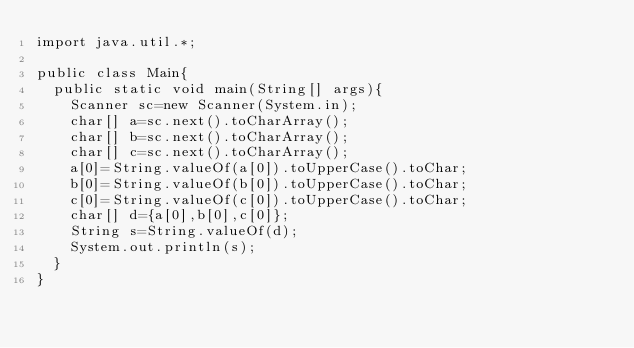<code> <loc_0><loc_0><loc_500><loc_500><_Java_>import java.util.*;

public class Main{
  public static void main(String[] args){
    Scanner sc=new Scanner(System.in);
    char[] a=sc.next().toCharArray();
    char[] b=sc.next().toCharArray();
    char[] c=sc.next().toCharArray();
    a[0]=String.valueOf(a[0]).toUpperCase().toChar;
    b[0]=String.valueOf(b[0]).toUpperCase().toChar;
    c[0]=String.valueOf(c[0]).toUpperCase().toChar;
    char[] d={a[0],b[0],c[0]};
    String s=String.valueOf(d);
    System.out.println(s);
  }
}</code> 